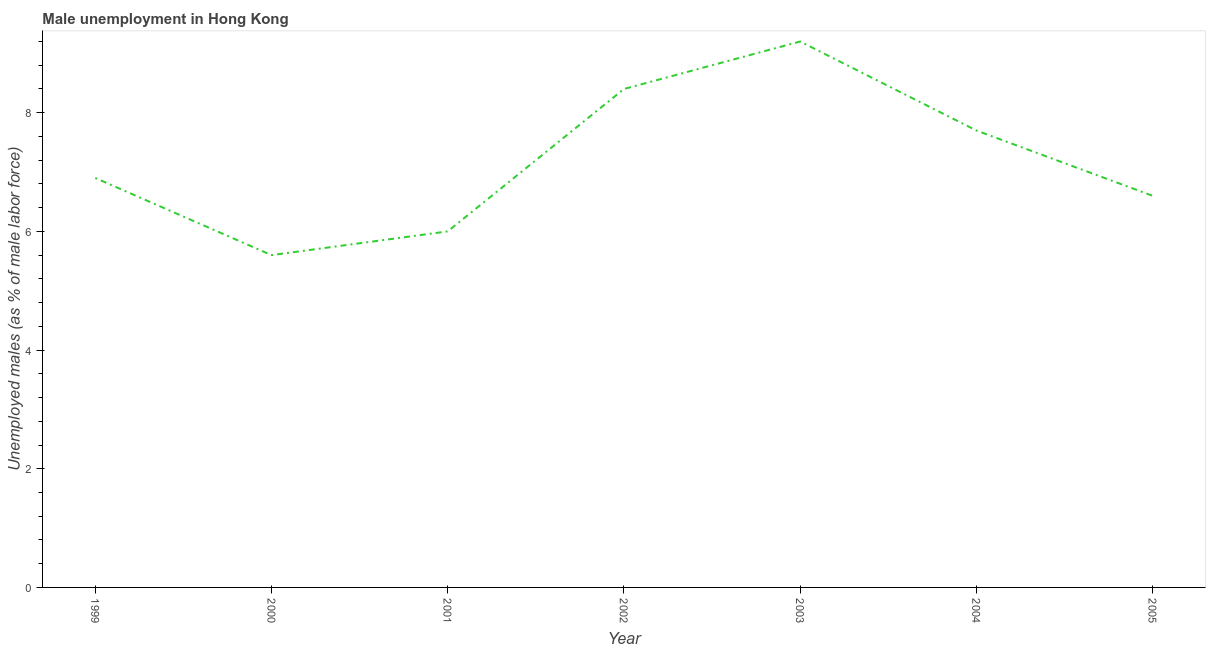What is the unemployed males population in 2001?
Offer a terse response. 6. Across all years, what is the maximum unemployed males population?
Offer a very short reply. 9.2. Across all years, what is the minimum unemployed males population?
Provide a short and direct response. 5.6. In which year was the unemployed males population maximum?
Make the answer very short. 2003. In which year was the unemployed males population minimum?
Your answer should be compact. 2000. What is the sum of the unemployed males population?
Ensure brevity in your answer.  50.4. What is the difference between the unemployed males population in 1999 and 2004?
Your answer should be very brief. -0.8. What is the average unemployed males population per year?
Your answer should be very brief. 7.2. What is the median unemployed males population?
Offer a very short reply. 6.9. What is the ratio of the unemployed males population in 1999 to that in 2004?
Offer a very short reply. 0.9. Is the unemployed males population in 1999 less than that in 2003?
Provide a succinct answer. Yes. What is the difference between the highest and the second highest unemployed males population?
Provide a succinct answer. 0.8. What is the difference between the highest and the lowest unemployed males population?
Offer a terse response. 3.6. How many lines are there?
Give a very brief answer. 1. Does the graph contain any zero values?
Offer a very short reply. No. What is the title of the graph?
Your response must be concise. Male unemployment in Hong Kong. What is the label or title of the Y-axis?
Ensure brevity in your answer.  Unemployed males (as % of male labor force). What is the Unemployed males (as % of male labor force) of 1999?
Your response must be concise. 6.9. What is the Unemployed males (as % of male labor force) of 2000?
Give a very brief answer. 5.6. What is the Unemployed males (as % of male labor force) of 2001?
Your answer should be compact. 6. What is the Unemployed males (as % of male labor force) of 2002?
Your response must be concise. 8.4. What is the Unemployed males (as % of male labor force) in 2003?
Give a very brief answer. 9.2. What is the Unemployed males (as % of male labor force) in 2004?
Provide a short and direct response. 7.7. What is the Unemployed males (as % of male labor force) in 2005?
Offer a very short reply. 6.6. What is the difference between the Unemployed males (as % of male labor force) in 1999 and 2003?
Provide a short and direct response. -2.3. What is the difference between the Unemployed males (as % of male labor force) in 1999 and 2004?
Your answer should be compact. -0.8. What is the difference between the Unemployed males (as % of male labor force) in 2000 and 2002?
Offer a very short reply. -2.8. What is the difference between the Unemployed males (as % of male labor force) in 2000 and 2003?
Keep it short and to the point. -3.6. What is the difference between the Unemployed males (as % of male labor force) in 2001 and 2005?
Give a very brief answer. -0.6. What is the difference between the Unemployed males (as % of male labor force) in 2002 and 2005?
Offer a terse response. 1.8. What is the difference between the Unemployed males (as % of male labor force) in 2003 and 2005?
Ensure brevity in your answer.  2.6. What is the ratio of the Unemployed males (as % of male labor force) in 1999 to that in 2000?
Provide a short and direct response. 1.23. What is the ratio of the Unemployed males (as % of male labor force) in 1999 to that in 2001?
Your answer should be compact. 1.15. What is the ratio of the Unemployed males (as % of male labor force) in 1999 to that in 2002?
Give a very brief answer. 0.82. What is the ratio of the Unemployed males (as % of male labor force) in 1999 to that in 2003?
Your response must be concise. 0.75. What is the ratio of the Unemployed males (as % of male labor force) in 1999 to that in 2004?
Your response must be concise. 0.9. What is the ratio of the Unemployed males (as % of male labor force) in 1999 to that in 2005?
Give a very brief answer. 1.04. What is the ratio of the Unemployed males (as % of male labor force) in 2000 to that in 2001?
Ensure brevity in your answer.  0.93. What is the ratio of the Unemployed males (as % of male labor force) in 2000 to that in 2002?
Ensure brevity in your answer.  0.67. What is the ratio of the Unemployed males (as % of male labor force) in 2000 to that in 2003?
Provide a short and direct response. 0.61. What is the ratio of the Unemployed males (as % of male labor force) in 2000 to that in 2004?
Offer a very short reply. 0.73. What is the ratio of the Unemployed males (as % of male labor force) in 2000 to that in 2005?
Offer a very short reply. 0.85. What is the ratio of the Unemployed males (as % of male labor force) in 2001 to that in 2002?
Offer a very short reply. 0.71. What is the ratio of the Unemployed males (as % of male labor force) in 2001 to that in 2003?
Provide a succinct answer. 0.65. What is the ratio of the Unemployed males (as % of male labor force) in 2001 to that in 2004?
Make the answer very short. 0.78. What is the ratio of the Unemployed males (as % of male labor force) in 2001 to that in 2005?
Provide a short and direct response. 0.91. What is the ratio of the Unemployed males (as % of male labor force) in 2002 to that in 2004?
Give a very brief answer. 1.09. What is the ratio of the Unemployed males (as % of male labor force) in 2002 to that in 2005?
Make the answer very short. 1.27. What is the ratio of the Unemployed males (as % of male labor force) in 2003 to that in 2004?
Provide a succinct answer. 1.2. What is the ratio of the Unemployed males (as % of male labor force) in 2003 to that in 2005?
Make the answer very short. 1.39. What is the ratio of the Unemployed males (as % of male labor force) in 2004 to that in 2005?
Make the answer very short. 1.17. 